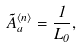<formula> <loc_0><loc_0><loc_500><loc_500>\tilde { A } _ { a } ^ { \langle n \rangle } = \frac { 1 } { L _ { 0 } } ,</formula> 